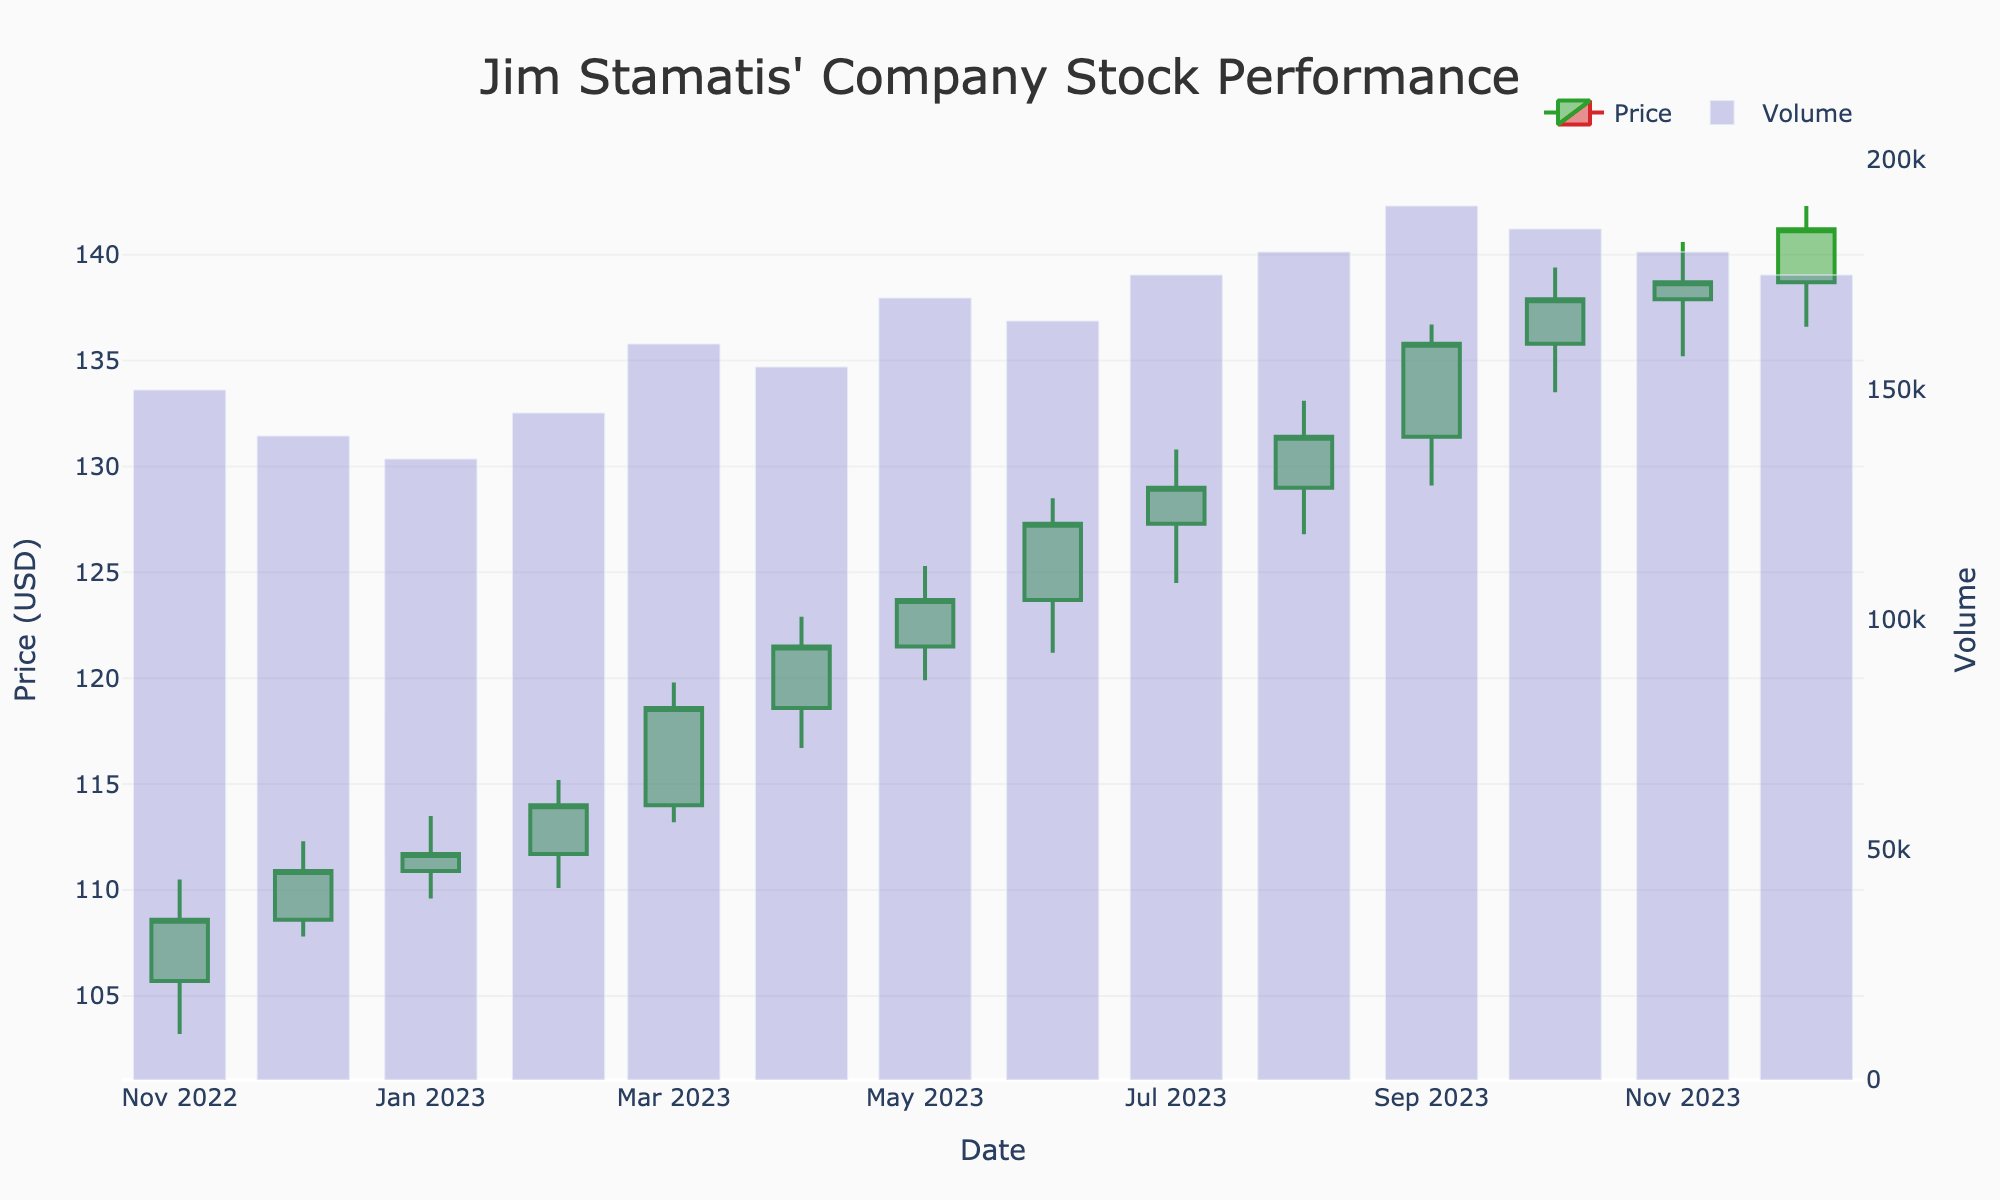what's the title of the figure? The title is displayed prominently at the top of the figure. It provides a quick reference to the content of the plot.
Answer: Jim Stamatis' Company Stock Performance how many data points are represented in the candlestick plot? Each candlestick represents one month's data. By counting the candlesticks from November 2022 to December 2023, we identify 14 data points.
Answer: 14 What is the price range of the stock in March 2023? The price range for a specific month can be identified by looking at the high and low points of the candlestick for that month. In March 2023, the highest price is 119.8 and the lowest is 113.2, giving a range of 119.8 - 113.2 = 6.6 USD.
Answer: 6.6 USD How did the stock close in December 2022 compared to January 2023? Compare the close prices of December 2022 and January 2023 from the data: December 2022 closed at 110.9 and January 2023 closed at 111.7. The difference is 111.7 - 110.9 = 0.8 USD higher in January.
Answer: 0.8 USD higher Which month had the highest trading volume, and what was the value? The bar chart below the candlestick plot shows the volume. The highest bar corresponds to September 2023 with a volume of 190,000.
Answer: September 2023, 190,000 Did the stock price increase or decrease from June 2023 to July 2023? By comparing the closing prices on the candlestick plot for June and July: June closed at 127.3 and July closed at 129.0. Thus, the price increased by 129.0 - 127.3 = 1.7 USD.
Answer: Increased, 1.7 USD What is the overall trend of the stock price across the year? The trend can be observed by looking at the overall direction of the candlesticks from left (starting from November 2022) to right (ending in December 2023). The stock started at a close of 108.6 in November 2022 and ended at 141.2 in December 2023, indicating an upward trend.
Answer: Upward trend What was the largest single-month price increase and in which month did it occur? Calculate the monthly differences in closing prices and identify the largest increase. Comparing months, the largest increase is from March to April 2023, where the closing prices changed from 118.6 to 121.5, a difference of 121.5 - 118.6 = 2.9 USD.
Answer: 2.9 USD, April 2023 Which month reported the lowest stock price, and what was the value? The lowest stock price is seen by identifying the lowest point of the entire year's data. The data shows that November 2022 had a low of 103.2 USD, which is the lowest of the year.
Answer: November 2022, 103.2 USD 